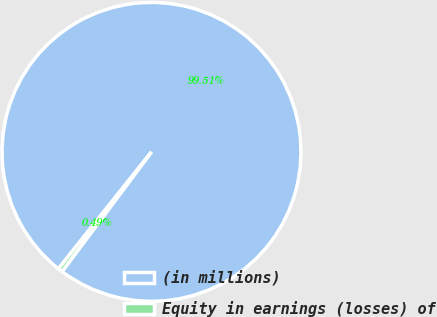<chart> <loc_0><loc_0><loc_500><loc_500><pie_chart><fcel>(in millions)<fcel>Equity in earnings (losses) of<nl><fcel>99.51%<fcel>0.49%<nl></chart> 